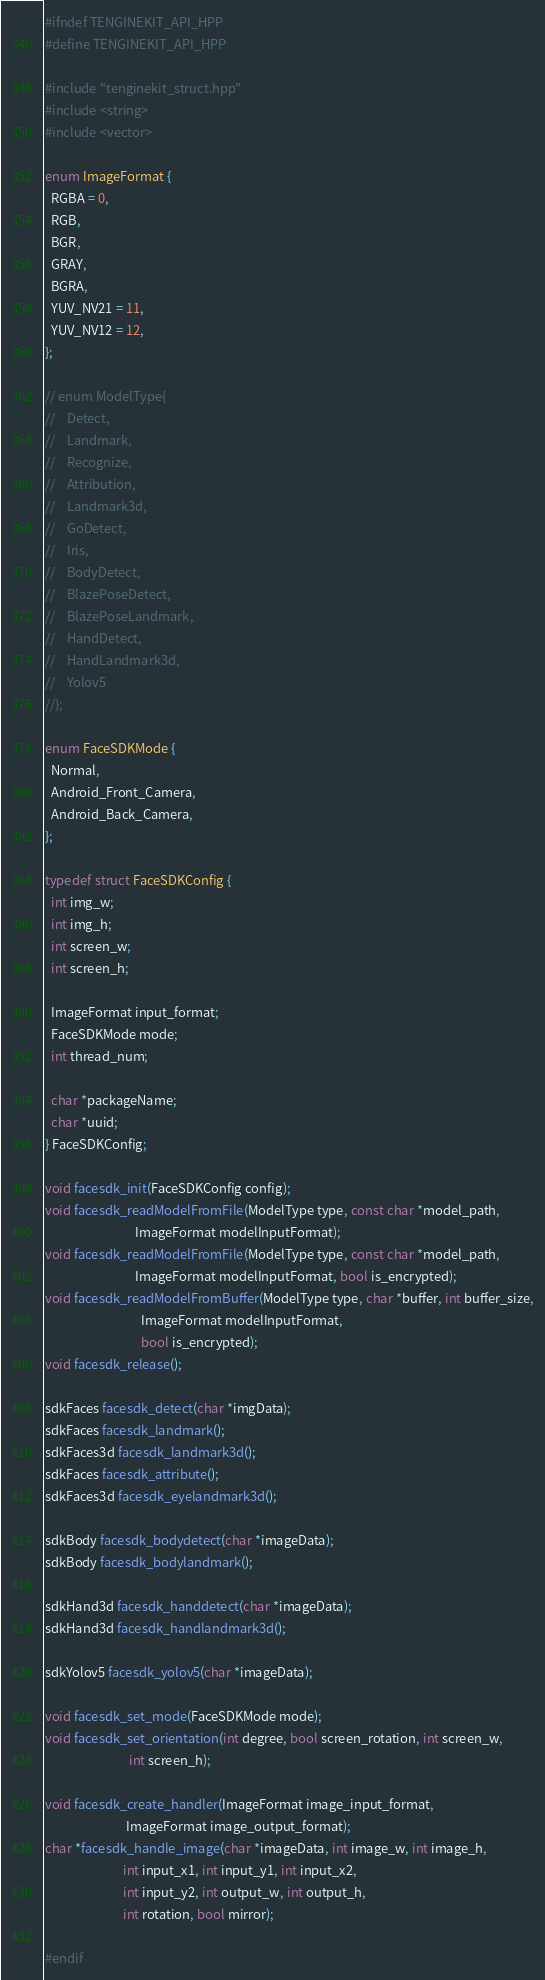<code> <loc_0><loc_0><loc_500><loc_500><_C++_>
#ifndef TENGINEKIT_API_HPP
#define TENGINEKIT_API_HPP

#include "tenginekit_struct.hpp"
#include <string>
#include <vector>

enum ImageFormat {
  RGBA = 0,
  RGB,
  BGR,
  GRAY,
  BGRA,
  YUV_NV21 = 11,
  YUV_NV12 = 12,
};

// enum ModelType{
//    Detect,
//    Landmark,
//    Recognize,
//    Attribution,
//    Landmark3d,
//    GoDetect,
//    Iris,
//    BodyDetect,
//    BlazePoseDetect,
//    BlazePoseLandmark,
//    HandDetect,
//    HandLandmark3d,
//    Yolov5
//};

enum FaceSDKMode {
  Normal,
  Android_Front_Camera,
  Android_Back_Camera,
};

typedef struct FaceSDKConfig {
  int img_w;
  int img_h;
  int screen_w;
  int screen_h;

  ImageFormat input_format;
  FaceSDKMode mode;
  int thread_num;

  char *packageName;
  char *uuid;
} FaceSDKConfig;

void facesdk_init(FaceSDKConfig config);
void facesdk_readModelFromFile(ModelType type, const char *model_path,
                               ImageFormat modelInputFormat);
void facesdk_readModelFromFile(ModelType type, const char *model_path,
                               ImageFormat modelInputFormat, bool is_encrypted);
void facesdk_readModelFromBuffer(ModelType type, char *buffer, int buffer_size,
                                 ImageFormat modelInputFormat,
                                 bool is_encrypted);
void facesdk_release();

sdkFaces facesdk_detect(char *imgData);
sdkFaces facesdk_landmark();
sdkFaces3d facesdk_landmark3d();
sdkFaces facesdk_attribute();
sdkFaces3d facesdk_eyelandmark3d();

sdkBody facesdk_bodydetect(char *imageData);
sdkBody facesdk_bodylandmark();

sdkHand3d facesdk_handdetect(char *imageData);
sdkHand3d facesdk_handlandmark3d();

sdkYolov5 facesdk_yolov5(char *imageData);

void facesdk_set_mode(FaceSDKMode mode);
void facesdk_set_orientation(int degree, bool screen_rotation, int screen_w,
                             int screen_h);

void facesdk_create_handler(ImageFormat image_input_format,
                            ImageFormat image_output_format);
char *facesdk_handle_image(char *imageData, int image_w, int image_h,
                           int input_x1, int input_y1, int input_x2,
                           int input_y2, int output_w, int output_h,
                           int rotation, bool mirror);

#endif
</code> 